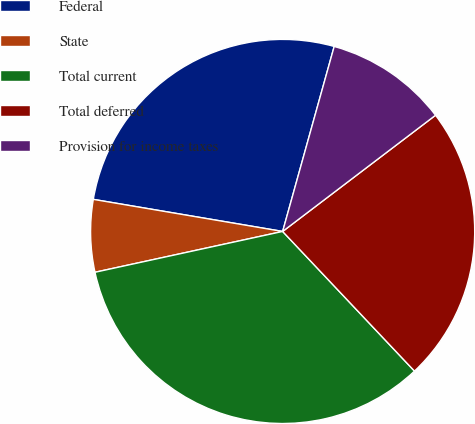Convert chart to OTSL. <chart><loc_0><loc_0><loc_500><loc_500><pie_chart><fcel>Federal<fcel>State<fcel>Total current<fcel>Total deferred<fcel>Provision for income taxes<nl><fcel>26.65%<fcel>6.08%<fcel>33.63%<fcel>23.3%<fcel>10.33%<nl></chart> 